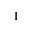Convert formula to latex. <formula><loc_0><loc_0><loc_500><loc_500>^ { 1 }</formula> 